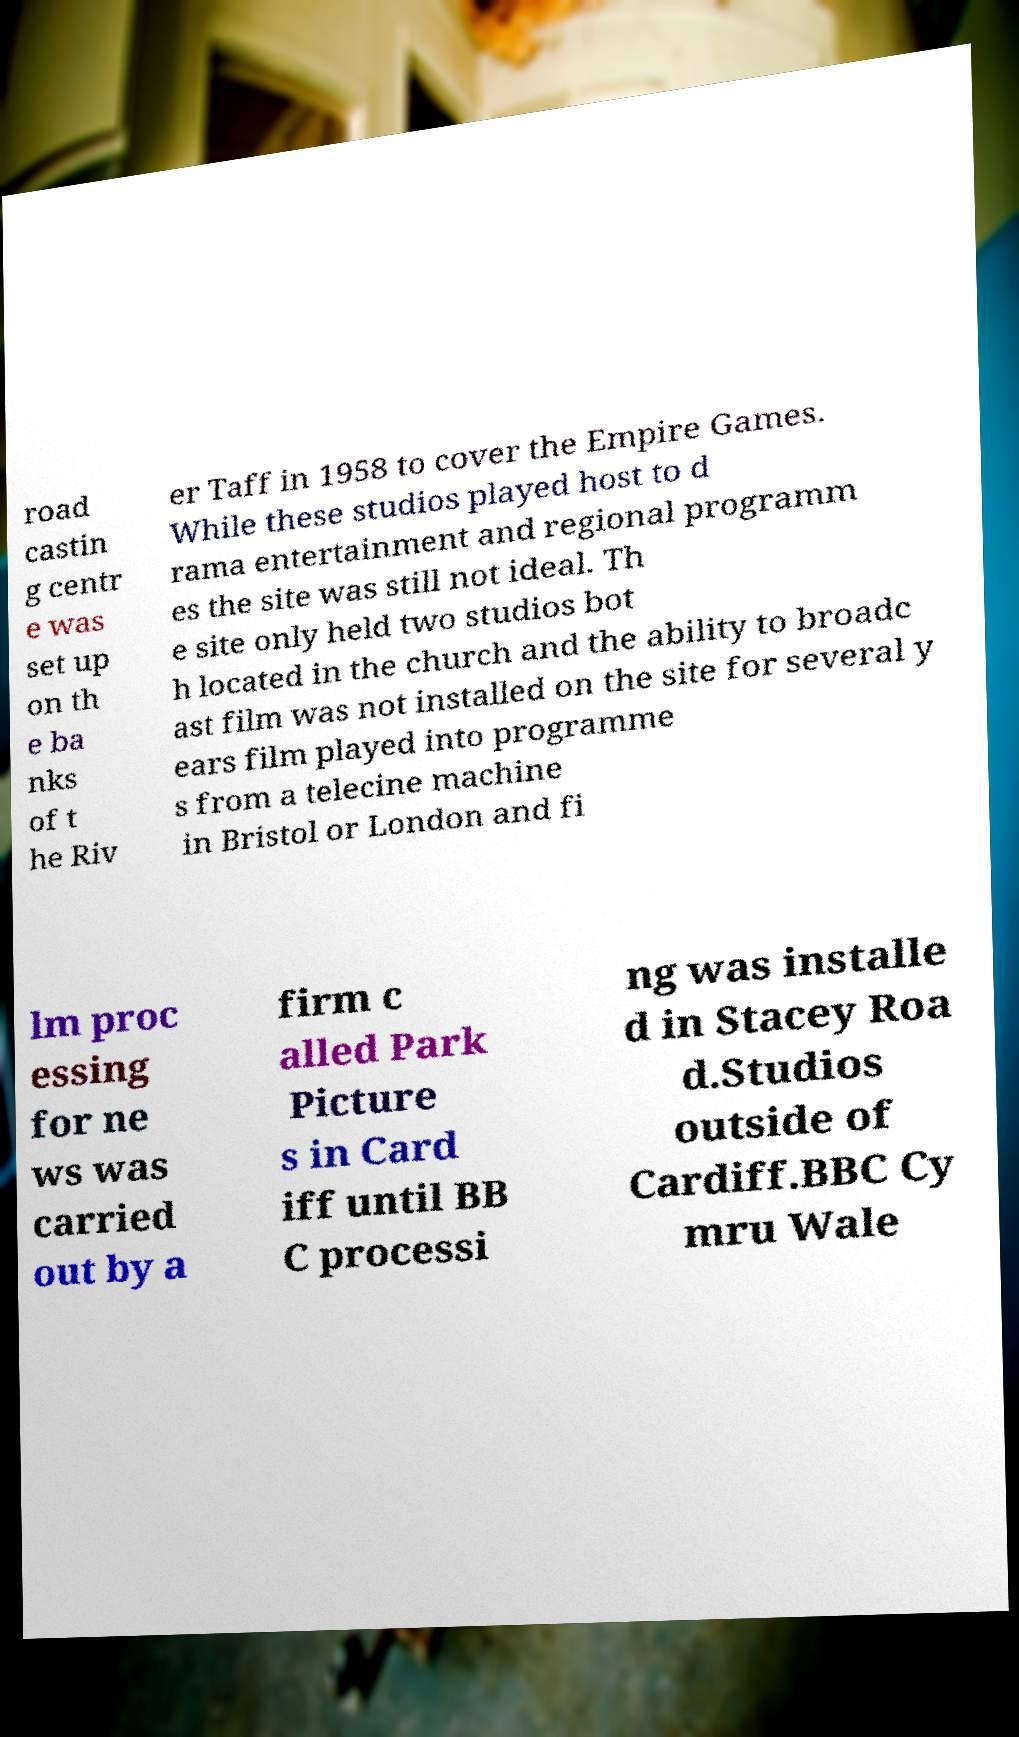I need the written content from this picture converted into text. Can you do that? road castin g centr e was set up on th e ba nks of t he Riv er Taff in 1958 to cover the Empire Games. While these studios played host to d rama entertainment and regional programm es the site was still not ideal. Th e site only held two studios bot h located in the church and the ability to broadc ast film was not installed on the site for several y ears film played into programme s from a telecine machine in Bristol or London and fi lm proc essing for ne ws was carried out by a firm c alled Park Picture s in Card iff until BB C processi ng was installe d in Stacey Roa d.Studios outside of Cardiff.BBC Cy mru Wale 